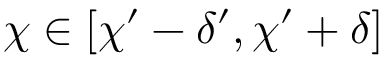Convert formula to latex. <formula><loc_0><loc_0><loc_500><loc_500>\chi \in [ \chi ^ { \prime } - \delta ^ { \prime } , \chi ^ { \prime } + \delta ]</formula> 